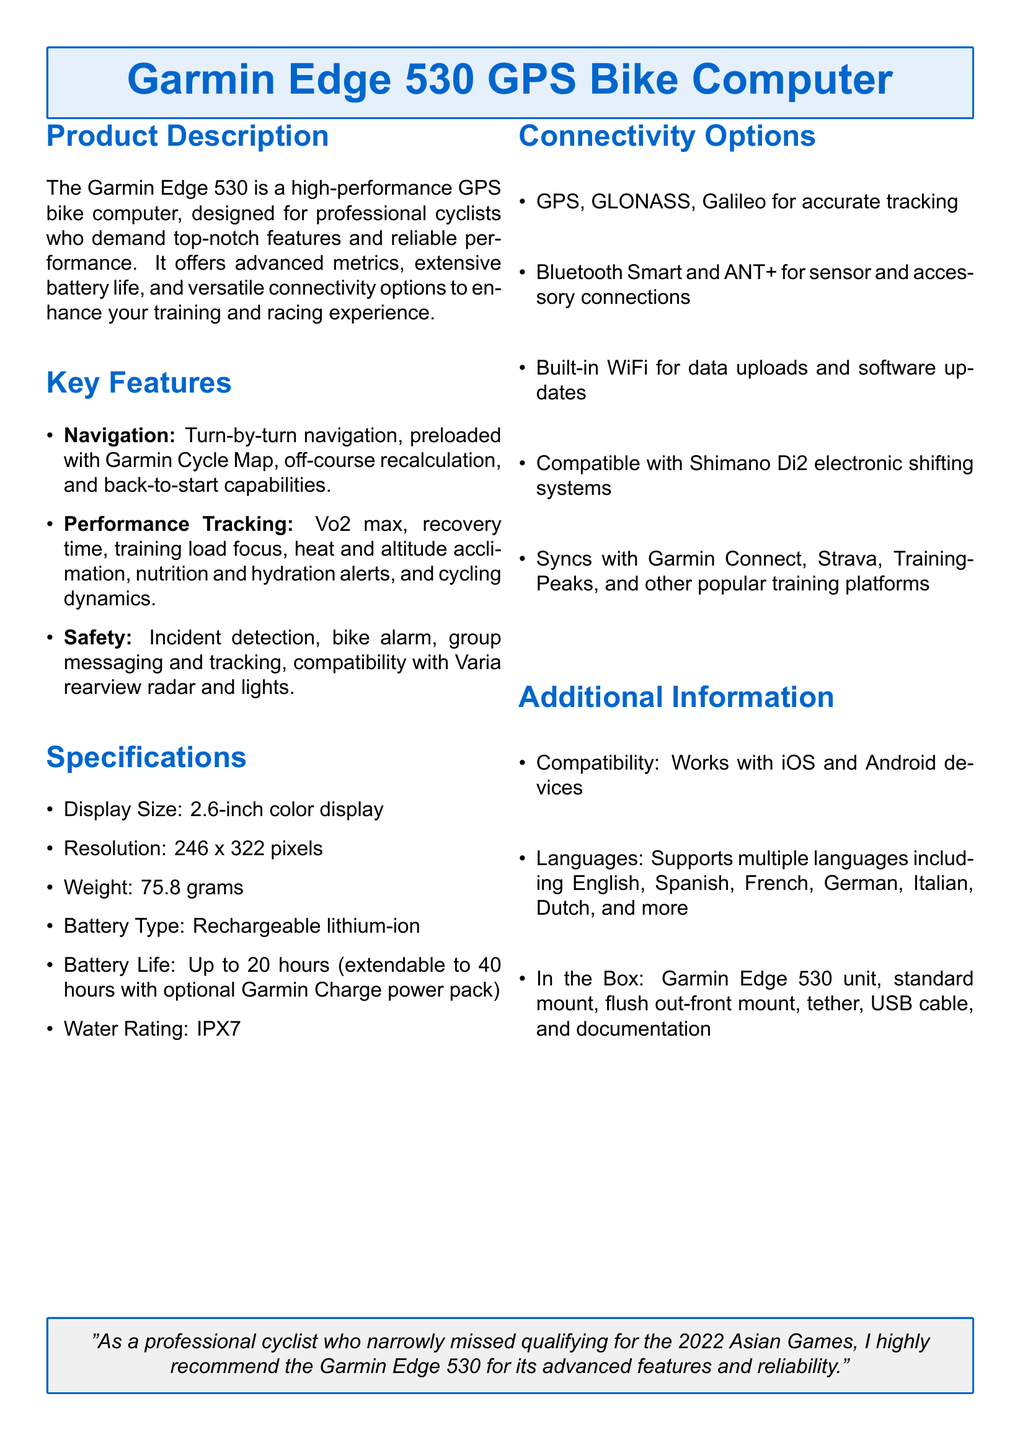What is the display size? The display size is specified in the document under specifications, stating a 2.6-inch color display.
Answer: 2.6-inch What is the battery life without an optional power pack? The battery life can be found in the specifications section, indicating it lasts up to 20 hours without the optional power pack.
Answer: Up to 20 hours What type of battery does the Garmin Edge 530 use? The type of battery is listed under specifications as a rechargeable lithium-ion battery.
Answer: Rechargeable lithium-ion Which connectivity options are supported? The connectivity options are detailed in the document, including GPS, GLONASS, Galileo, Bluetooth Smart, ANT+, and built-in WiFi.
Answer: GPS, GLONASS, Galileo, Bluetooth Smart, ANT+, built-in WiFi What safety feature helps track incidents? The safety features mentioned include incident detection, which is specifically noted in the key features section.
Answer: Incident detection How much does the Garmin Edge 530 weigh? The weight is provided in the specifications list, which states the weight is 75.8 grams.
Answer: 75.8 grams What is the water rating of the Garmin Edge 530? The water rating is listed under specifications, indicating it has an IPX7 rating.
Answer: IPX7 Which platforms can the Garmin Edge 530 sync with? The compatible platforms are specified in the connectivity options, listing Garmin Connect, Strava, and TrainingPeaks among others.
Answer: Garmin Connect, Strava, TrainingPeaks What does the box contain? The contents of the box are outlined in the additional information section, specifying the unit, mounts, tether, USB cable, and documentation.
Answer: Garmin Edge 530 unit, standard mount, flush out-front mount, tether, USB cable, documentation 